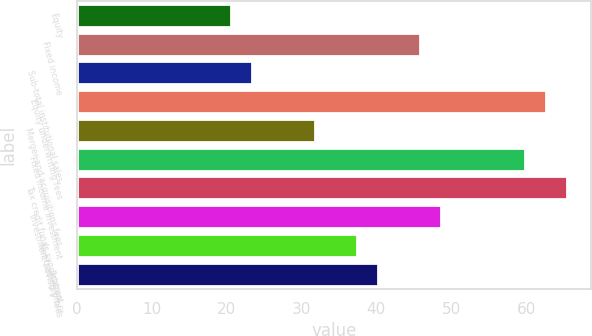<chart> <loc_0><loc_0><loc_500><loc_500><bar_chart><fcel>Equity<fcel>Fixed income<fcel>Sub-total institutional sales<fcel>Equity underwriting fees<fcel>Merger and acquisitions fees<fcel>Fixed income investment<fcel>Tax credit funds syndication<fcel>Investment advisory fees<fcel>Net trading profit<fcel>Interest<nl><fcel>20.6<fcel>45.8<fcel>23.4<fcel>62.6<fcel>31.8<fcel>59.8<fcel>65.4<fcel>48.6<fcel>37.4<fcel>40.2<nl></chart> 